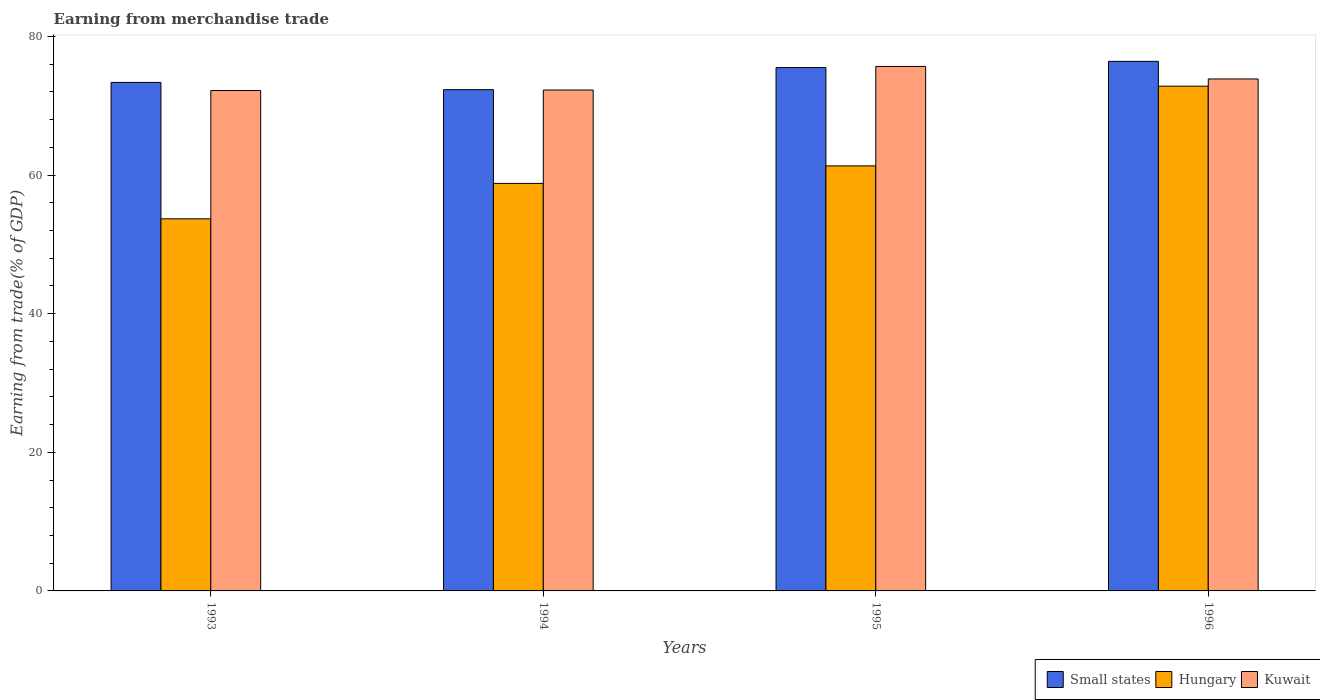Are the number of bars per tick equal to the number of legend labels?
Provide a short and direct response. Yes. How many bars are there on the 1st tick from the left?
Keep it short and to the point. 3. How many bars are there on the 2nd tick from the right?
Provide a short and direct response. 3. What is the earnings from trade in Kuwait in 1996?
Offer a very short reply. 73.86. Across all years, what is the maximum earnings from trade in Kuwait?
Ensure brevity in your answer.  75.67. Across all years, what is the minimum earnings from trade in Small states?
Your response must be concise. 72.32. In which year was the earnings from trade in Kuwait maximum?
Your answer should be compact. 1995. In which year was the earnings from trade in Kuwait minimum?
Provide a succinct answer. 1993. What is the total earnings from trade in Small states in the graph?
Provide a short and direct response. 297.59. What is the difference between the earnings from trade in Hungary in 1995 and that in 1996?
Your response must be concise. -11.5. What is the difference between the earnings from trade in Hungary in 1993 and the earnings from trade in Small states in 1996?
Give a very brief answer. -22.72. What is the average earnings from trade in Hungary per year?
Make the answer very short. 61.65. In the year 1995, what is the difference between the earnings from trade in Small states and earnings from trade in Hungary?
Offer a very short reply. 14.18. What is the ratio of the earnings from trade in Hungary in 1993 to that in 1996?
Your answer should be compact. 0.74. Is the difference between the earnings from trade in Small states in 1993 and 1996 greater than the difference between the earnings from trade in Hungary in 1993 and 1996?
Offer a very short reply. Yes. What is the difference between the highest and the second highest earnings from trade in Small states?
Offer a very short reply. 0.9. What is the difference between the highest and the lowest earnings from trade in Kuwait?
Ensure brevity in your answer.  3.47. In how many years, is the earnings from trade in Small states greater than the average earnings from trade in Small states taken over all years?
Your answer should be compact. 2. Is the sum of the earnings from trade in Kuwait in 1993 and 1994 greater than the maximum earnings from trade in Hungary across all years?
Give a very brief answer. Yes. What does the 1st bar from the left in 1993 represents?
Offer a very short reply. Small states. What does the 3rd bar from the right in 1995 represents?
Ensure brevity in your answer.  Small states. Are all the bars in the graph horizontal?
Your answer should be compact. No. How many years are there in the graph?
Provide a short and direct response. 4. What is the difference between two consecutive major ticks on the Y-axis?
Make the answer very short. 20. Does the graph contain grids?
Ensure brevity in your answer.  No. How are the legend labels stacked?
Offer a very short reply. Horizontal. What is the title of the graph?
Offer a very short reply. Earning from merchandise trade. Does "High income" appear as one of the legend labels in the graph?
Make the answer very short. No. What is the label or title of the X-axis?
Your answer should be compact. Years. What is the label or title of the Y-axis?
Offer a terse response. Earning from trade(% of GDP). What is the Earning from trade(% of GDP) in Small states in 1993?
Make the answer very short. 73.36. What is the Earning from trade(% of GDP) of Hungary in 1993?
Give a very brief answer. 53.68. What is the Earning from trade(% of GDP) of Kuwait in 1993?
Offer a very short reply. 72.19. What is the Earning from trade(% of GDP) of Small states in 1994?
Make the answer very short. 72.32. What is the Earning from trade(% of GDP) in Hungary in 1994?
Your response must be concise. 58.79. What is the Earning from trade(% of GDP) in Kuwait in 1994?
Give a very brief answer. 72.27. What is the Earning from trade(% of GDP) of Small states in 1995?
Provide a succinct answer. 75.5. What is the Earning from trade(% of GDP) of Hungary in 1995?
Your response must be concise. 61.32. What is the Earning from trade(% of GDP) in Kuwait in 1995?
Provide a short and direct response. 75.67. What is the Earning from trade(% of GDP) of Small states in 1996?
Offer a very short reply. 76.4. What is the Earning from trade(% of GDP) of Hungary in 1996?
Your response must be concise. 72.82. What is the Earning from trade(% of GDP) in Kuwait in 1996?
Ensure brevity in your answer.  73.86. Across all years, what is the maximum Earning from trade(% of GDP) of Small states?
Keep it short and to the point. 76.4. Across all years, what is the maximum Earning from trade(% of GDP) of Hungary?
Give a very brief answer. 72.82. Across all years, what is the maximum Earning from trade(% of GDP) of Kuwait?
Keep it short and to the point. 75.67. Across all years, what is the minimum Earning from trade(% of GDP) in Small states?
Offer a terse response. 72.32. Across all years, what is the minimum Earning from trade(% of GDP) in Hungary?
Your response must be concise. 53.68. Across all years, what is the minimum Earning from trade(% of GDP) of Kuwait?
Offer a terse response. 72.19. What is the total Earning from trade(% of GDP) in Small states in the graph?
Keep it short and to the point. 297.59. What is the total Earning from trade(% of GDP) of Hungary in the graph?
Give a very brief answer. 246.62. What is the total Earning from trade(% of GDP) of Kuwait in the graph?
Your answer should be compact. 293.99. What is the difference between the Earning from trade(% of GDP) in Small states in 1993 and that in 1994?
Your response must be concise. 1.05. What is the difference between the Earning from trade(% of GDP) in Hungary in 1993 and that in 1994?
Make the answer very short. -5.11. What is the difference between the Earning from trade(% of GDP) of Kuwait in 1993 and that in 1994?
Make the answer very short. -0.07. What is the difference between the Earning from trade(% of GDP) in Small states in 1993 and that in 1995?
Make the answer very short. -2.14. What is the difference between the Earning from trade(% of GDP) of Hungary in 1993 and that in 1995?
Provide a succinct answer. -7.64. What is the difference between the Earning from trade(% of GDP) in Kuwait in 1993 and that in 1995?
Give a very brief answer. -3.47. What is the difference between the Earning from trade(% of GDP) of Small states in 1993 and that in 1996?
Ensure brevity in your answer.  -3.04. What is the difference between the Earning from trade(% of GDP) of Hungary in 1993 and that in 1996?
Your answer should be compact. -19.14. What is the difference between the Earning from trade(% of GDP) in Kuwait in 1993 and that in 1996?
Keep it short and to the point. -1.67. What is the difference between the Earning from trade(% of GDP) of Small states in 1994 and that in 1995?
Offer a terse response. -3.19. What is the difference between the Earning from trade(% of GDP) of Hungary in 1994 and that in 1995?
Offer a very short reply. -2.53. What is the difference between the Earning from trade(% of GDP) in Kuwait in 1994 and that in 1995?
Your response must be concise. -3.4. What is the difference between the Earning from trade(% of GDP) in Small states in 1994 and that in 1996?
Provide a succinct answer. -4.08. What is the difference between the Earning from trade(% of GDP) in Hungary in 1994 and that in 1996?
Your response must be concise. -14.03. What is the difference between the Earning from trade(% of GDP) in Kuwait in 1994 and that in 1996?
Ensure brevity in your answer.  -1.6. What is the difference between the Earning from trade(% of GDP) of Small states in 1995 and that in 1996?
Give a very brief answer. -0.9. What is the difference between the Earning from trade(% of GDP) in Hungary in 1995 and that in 1996?
Provide a short and direct response. -11.5. What is the difference between the Earning from trade(% of GDP) of Kuwait in 1995 and that in 1996?
Provide a succinct answer. 1.8. What is the difference between the Earning from trade(% of GDP) of Small states in 1993 and the Earning from trade(% of GDP) of Hungary in 1994?
Keep it short and to the point. 14.57. What is the difference between the Earning from trade(% of GDP) of Small states in 1993 and the Earning from trade(% of GDP) of Kuwait in 1994?
Provide a succinct answer. 1.1. What is the difference between the Earning from trade(% of GDP) in Hungary in 1993 and the Earning from trade(% of GDP) in Kuwait in 1994?
Your answer should be very brief. -18.58. What is the difference between the Earning from trade(% of GDP) in Small states in 1993 and the Earning from trade(% of GDP) in Hungary in 1995?
Your answer should be compact. 12.04. What is the difference between the Earning from trade(% of GDP) of Small states in 1993 and the Earning from trade(% of GDP) of Kuwait in 1995?
Provide a short and direct response. -2.3. What is the difference between the Earning from trade(% of GDP) of Hungary in 1993 and the Earning from trade(% of GDP) of Kuwait in 1995?
Your answer should be compact. -21.98. What is the difference between the Earning from trade(% of GDP) in Small states in 1993 and the Earning from trade(% of GDP) in Hungary in 1996?
Ensure brevity in your answer.  0.54. What is the difference between the Earning from trade(% of GDP) in Small states in 1993 and the Earning from trade(% of GDP) in Kuwait in 1996?
Your answer should be very brief. -0.5. What is the difference between the Earning from trade(% of GDP) in Hungary in 1993 and the Earning from trade(% of GDP) in Kuwait in 1996?
Your response must be concise. -20.18. What is the difference between the Earning from trade(% of GDP) in Small states in 1994 and the Earning from trade(% of GDP) in Hungary in 1995?
Your answer should be compact. 11. What is the difference between the Earning from trade(% of GDP) in Small states in 1994 and the Earning from trade(% of GDP) in Kuwait in 1995?
Offer a terse response. -3.35. What is the difference between the Earning from trade(% of GDP) of Hungary in 1994 and the Earning from trade(% of GDP) of Kuwait in 1995?
Offer a terse response. -16.87. What is the difference between the Earning from trade(% of GDP) of Small states in 1994 and the Earning from trade(% of GDP) of Hungary in 1996?
Your answer should be compact. -0.5. What is the difference between the Earning from trade(% of GDP) of Small states in 1994 and the Earning from trade(% of GDP) of Kuwait in 1996?
Provide a succinct answer. -1.54. What is the difference between the Earning from trade(% of GDP) in Hungary in 1994 and the Earning from trade(% of GDP) in Kuwait in 1996?
Your response must be concise. -15.07. What is the difference between the Earning from trade(% of GDP) of Small states in 1995 and the Earning from trade(% of GDP) of Hungary in 1996?
Provide a succinct answer. 2.68. What is the difference between the Earning from trade(% of GDP) of Small states in 1995 and the Earning from trade(% of GDP) of Kuwait in 1996?
Ensure brevity in your answer.  1.64. What is the difference between the Earning from trade(% of GDP) in Hungary in 1995 and the Earning from trade(% of GDP) in Kuwait in 1996?
Offer a terse response. -12.54. What is the average Earning from trade(% of GDP) in Small states per year?
Make the answer very short. 74.4. What is the average Earning from trade(% of GDP) of Hungary per year?
Offer a very short reply. 61.65. What is the average Earning from trade(% of GDP) in Kuwait per year?
Keep it short and to the point. 73.5. In the year 1993, what is the difference between the Earning from trade(% of GDP) in Small states and Earning from trade(% of GDP) in Hungary?
Make the answer very short. 19.68. In the year 1993, what is the difference between the Earning from trade(% of GDP) in Small states and Earning from trade(% of GDP) in Kuwait?
Your response must be concise. 1.17. In the year 1993, what is the difference between the Earning from trade(% of GDP) in Hungary and Earning from trade(% of GDP) in Kuwait?
Your answer should be very brief. -18.51. In the year 1994, what is the difference between the Earning from trade(% of GDP) of Small states and Earning from trade(% of GDP) of Hungary?
Your response must be concise. 13.53. In the year 1994, what is the difference between the Earning from trade(% of GDP) of Small states and Earning from trade(% of GDP) of Kuwait?
Keep it short and to the point. 0.05. In the year 1994, what is the difference between the Earning from trade(% of GDP) in Hungary and Earning from trade(% of GDP) in Kuwait?
Provide a short and direct response. -13.47. In the year 1995, what is the difference between the Earning from trade(% of GDP) of Small states and Earning from trade(% of GDP) of Hungary?
Make the answer very short. 14.18. In the year 1995, what is the difference between the Earning from trade(% of GDP) in Small states and Earning from trade(% of GDP) in Kuwait?
Your answer should be very brief. -0.16. In the year 1995, what is the difference between the Earning from trade(% of GDP) in Hungary and Earning from trade(% of GDP) in Kuwait?
Keep it short and to the point. -14.34. In the year 1996, what is the difference between the Earning from trade(% of GDP) in Small states and Earning from trade(% of GDP) in Hungary?
Provide a short and direct response. 3.58. In the year 1996, what is the difference between the Earning from trade(% of GDP) of Small states and Earning from trade(% of GDP) of Kuwait?
Offer a terse response. 2.54. In the year 1996, what is the difference between the Earning from trade(% of GDP) in Hungary and Earning from trade(% of GDP) in Kuwait?
Your answer should be very brief. -1.04. What is the ratio of the Earning from trade(% of GDP) of Small states in 1993 to that in 1994?
Give a very brief answer. 1.01. What is the ratio of the Earning from trade(% of GDP) of Hungary in 1993 to that in 1994?
Provide a succinct answer. 0.91. What is the ratio of the Earning from trade(% of GDP) of Small states in 1993 to that in 1995?
Your response must be concise. 0.97. What is the ratio of the Earning from trade(% of GDP) in Hungary in 1993 to that in 1995?
Offer a very short reply. 0.88. What is the ratio of the Earning from trade(% of GDP) in Kuwait in 1993 to that in 1995?
Give a very brief answer. 0.95. What is the ratio of the Earning from trade(% of GDP) in Small states in 1993 to that in 1996?
Make the answer very short. 0.96. What is the ratio of the Earning from trade(% of GDP) in Hungary in 1993 to that in 1996?
Give a very brief answer. 0.74. What is the ratio of the Earning from trade(% of GDP) of Kuwait in 1993 to that in 1996?
Provide a short and direct response. 0.98. What is the ratio of the Earning from trade(% of GDP) in Small states in 1994 to that in 1995?
Offer a terse response. 0.96. What is the ratio of the Earning from trade(% of GDP) in Hungary in 1994 to that in 1995?
Provide a succinct answer. 0.96. What is the ratio of the Earning from trade(% of GDP) of Kuwait in 1994 to that in 1995?
Your answer should be compact. 0.96. What is the ratio of the Earning from trade(% of GDP) in Small states in 1994 to that in 1996?
Ensure brevity in your answer.  0.95. What is the ratio of the Earning from trade(% of GDP) in Hungary in 1994 to that in 1996?
Ensure brevity in your answer.  0.81. What is the ratio of the Earning from trade(% of GDP) of Kuwait in 1994 to that in 1996?
Offer a terse response. 0.98. What is the ratio of the Earning from trade(% of GDP) in Small states in 1995 to that in 1996?
Provide a succinct answer. 0.99. What is the ratio of the Earning from trade(% of GDP) of Hungary in 1995 to that in 1996?
Provide a succinct answer. 0.84. What is the ratio of the Earning from trade(% of GDP) of Kuwait in 1995 to that in 1996?
Provide a short and direct response. 1.02. What is the difference between the highest and the second highest Earning from trade(% of GDP) in Small states?
Your answer should be very brief. 0.9. What is the difference between the highest and the second highest Earning from trade(% of GDP) of Hungary?
Your answer should be compact. 11.5. What is the difference between the highest and the second highest Earning from trade(% of GDP) in Kuwait?
Provide a short and direct response. 1.8. What is the difference between the highest and the lowest Earning from trade(% of GDP) in Small states?
Make the answer very short. 4.08. What is the difference between the highest and the lowest Earning from trade(% of GDP) of Hungary?
Give a very brief answer. 19.14. What is the difference between the highest and the lowest Earning from trade(% of GDP) in Kuwait?
Make the answer very short. 3.47. 